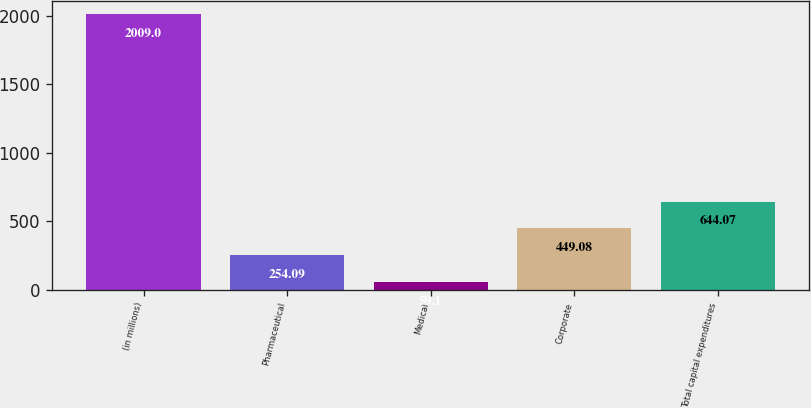<chart> <loc_0><loc_0><loc_500><loc_500><bar_chart><fcel>(in millions)<fcel>Pharmaceutical<fcel>Medical<fcel>Corporate<fcel>Total capital expenditures<nl><fcel>2009<fcel>254.09<fcel>59.1<fcel>449.08<fcel>644.07<nl></chart> 